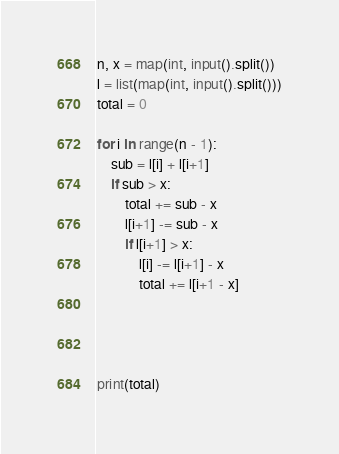Convert code to text. <code><loc_0><loc_0><loc_500><loc_500><_Python_>
n, x = map(int, input().split())
l = list(map(int, input().split()))
total = 0

for i in range(n - 1):
    sub = l[i] + l[i+1]
    if sub > x:
        total += sub - x
        l[i+1] -= sub - x
        if l[i+1] > x:
            l[i] -= l[i+1] - x
            total += l[i+1 - x]




print(total)</code> 